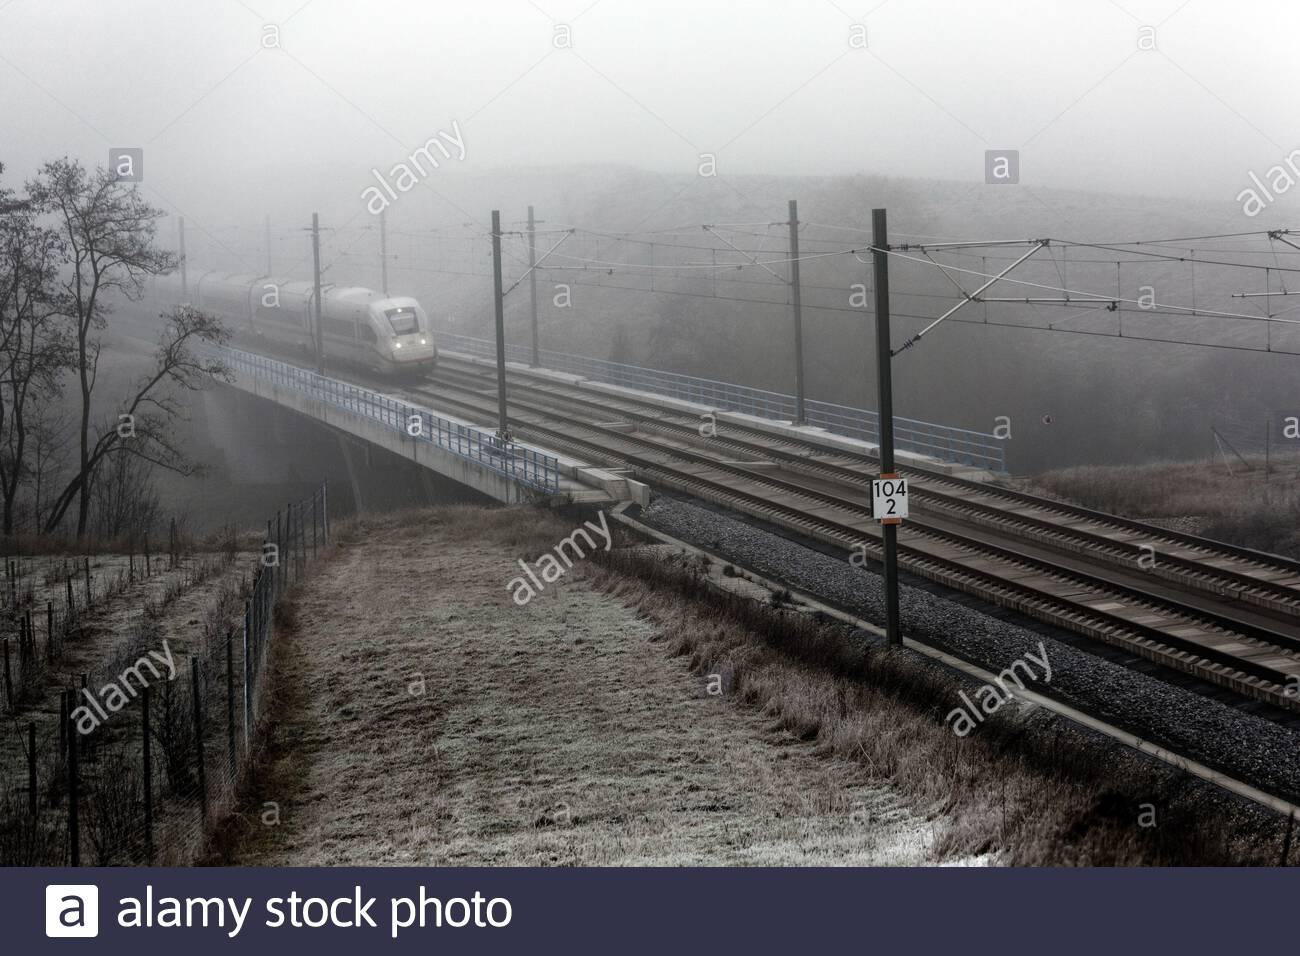What kind of weather conditions are depicted in this image? The image shows a foggy and possibly cold morning, as indicated by the mist and the frost on the ground. 